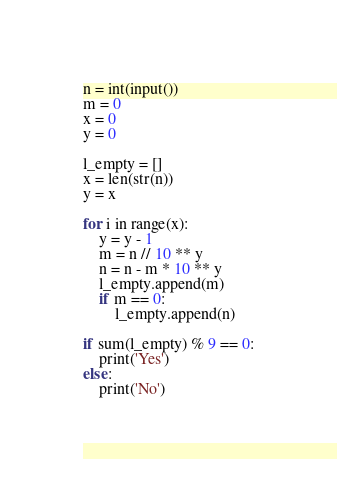Convert code to text. <code><loc_0><loc_0><loc_500><loc_500><_Python_>n = int(input())
m = 0
x = 0
y = 0

l_empty = []
x = len(str(n))
y = x

for i in range(x):
    y = y - 1
    m = n // 10 ** y
    n = n - m * 10 ** y
    l_empty.append(m)
    if m == 0:
        l_empty.append(n)

if sum(l_empty) % 9 == 0:
    print('Yes')
else:
    print('No')</code> 